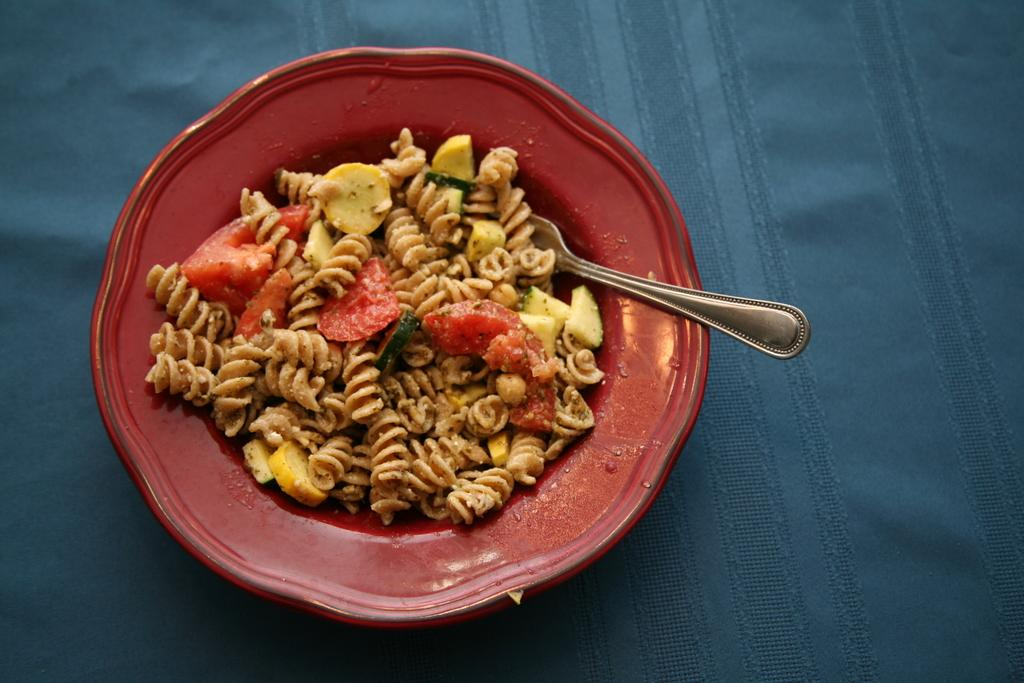What type of objects can be seen in the image? There are food items in the image. What utensil is present in the image? There is a spoon in the image. Where is the spoon located? The spoon is in a bowl. What is the color of the cloth on which the bowl is placed? The bowl is placed on a blue color cloth. What type of attention is the banana receiving in the image? There is no banana present in the image, so it cannot receive any attention. 